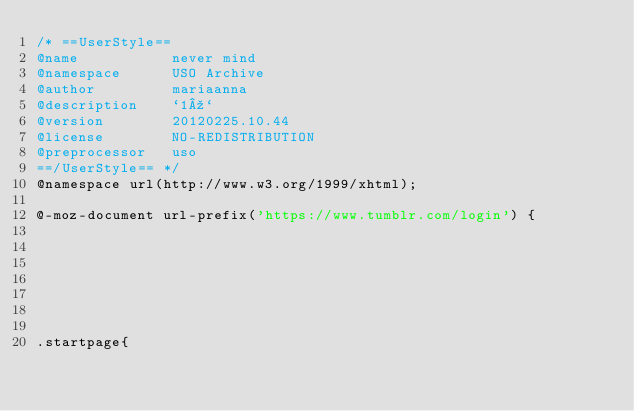<code> <loc_0><loc_0><loc_500><loc_500><_CSS_>/* ==UserStyle==
@name           never mind
@namespace      USO Archive
@author         mariaanna
@description    `1º`
@version        20120225.10.44
@license        NO-REDISTRIBUTION
@preprocessor   uso
==/UserStyle== */
@namespace url(http://www.w3.org/1999/xhtml);

@-moz-document url-prefix('https://www.tumblr.com/login') {







.startpage{</code> 